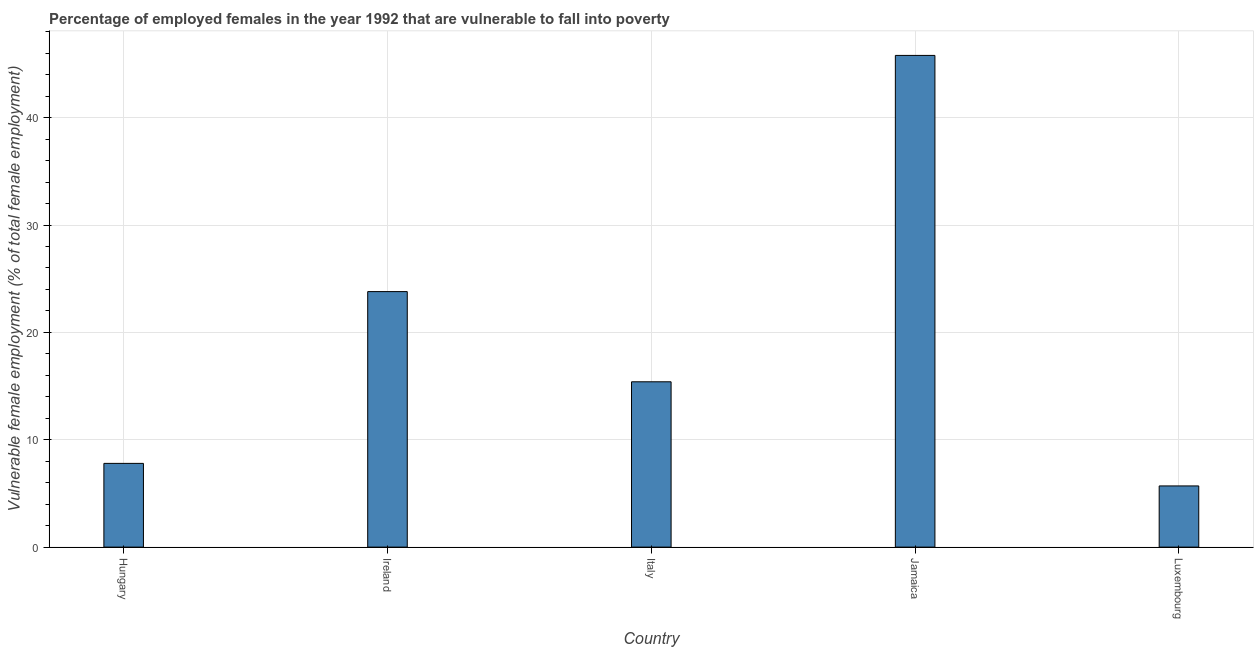What is the title of the graph?
Keep it short and to the point. Percentage of employed females in the year 1992 that are vulnerable to fall into poverty. What is the label or title of the X-axis?
Provide a short and direct response. Country. What is the label or title of the Y-axis?
Make the answer very short. Vulnerable female employment (% of total female employment). What is the percentage of employed females who are vulnerable to fall into poverty in Jamaica?
Provide a succinct answer. 45.8. Across all countries, what is the maximum percentage of employed females who are vulnerable to fall into poverty?
Offer a very short reply. 45.8. Across all countries, what is the minimum percentage of employed females who are vulnerable to fall into poverty?
Give a very brief answer. 5.7. In which country was the percentage of employed females who are vulnerable to fall into poverty maximum?
Ensure brevity in your answer.  Jamaica. In which country was the percentage of employed females who are vulnerable to fall into poverty minimum?
Your response must be concise. Luxembourg. What is the sum of the percentage of employed females who are vulnerable to fall into poverty?
Your answer should be compact. 98.5. What is the difference between the percentage of employed females who are vulnerable to fall into poverty in Ireland and Italy?
Make the answer very short. 8.4. What is the average percentage of employed females who are vulnerable to fall into poverty per country?
Provide a short and direct response. 19.7. What is the median percentage of employed females who are vulnerable to fall into poverty?
Ensure brevity in your answer.  15.4. In how many countries, is the percentage of employed females who are vulnerable to fall into poverty greater than 44 %?
Your answer should be very brief. 1. What is the ratio of the percentage of employed females who are vulnerable to fall into poverty in Italy to that in Jamaica?
Make the answer very short. 0.34. Is the difference between the percentage of employed females who are vulnerable to fall into poverty in Italy and Luxembourg greater than the difference between any two countries?
Your answer should be compact. No. Is the sum of the percentage of employed females who are vulnerable to fall into poverty in Italy and Jamaica greater than the maximum percentage of employed females who are vulnerable to fall into poverty across all countries?
Give a very brief answer. Yes. What is the difference between the highest and the lowest percentage of employed females who are vulnerable to fall into poverty?
Your answer should be compact. 40.1. In how many countries, is the percentage of employed females who are vulnerable to fall into poverty greater than the average percentage of employed females who are vulnerable to fall into poverty taken over all countries?
Make the answer very short. 2. How many bars are there?
Provide a succinct answer. 5. Are the values on the major ticks of Y-axis written in scientific E-notation?
Ensure brevity in your answer.  No. What is the Vulnerable female employment (% of total female employment) of Hungary?
Your answer should be compact. 7.8. What is the Vulnerable female employment (% of total female employment) of Ireland?
Offer a terse response. 23.8. What is the Vulnerable female employment (% of total female employment) of Italy?
Your response must be concise. 15.4. What is the Vulnerable female employment (% of total female employment) of Jamaica?
Give a very brief answer. 45.8. What is the Vulnerable female employment (% of total female employment) in Luxembourg?
Keep it short and to the point. 5.7. What is the difference between the Vulnerable female employment (% of total female employment) in Hungary and Ireland?
Ensure brevity in your answer.  -16. What is the difference between the Vulnerable female employment (% of total female employment) in Hungary and Italy?
Make the answer very short. -7.6. What is the difference between the Vulnerable female employment (% of total female employment) in Hungary and Jamaica?
Make the answer very short. -38. What is the difference between the Vulnerable female employment (% of total female employment) in Ireland and Italy?
Keep it short and to the point. 8.4. What is the difference between the Vulnerable female employment (% of total female employment) in Ireland and Jamaica?
Provide a succinct answer. -22. What is the difference between the Vulnerable female employment (% of total female employment) in Ireland and Luxembourg?
Offer a very short reply. 18.1. What is the difference between the Vulnerable female employment (% of total female employment) in Italy and Jamaica?
Offer a very short reply. -30.4. What is the difference between the Vulnerable female employment (% of total female employment) in Jamaica and Luxembourg?
Keep it short and to the point. 40.1. What is the ratio of the Vulnerable female employment (% of total female employment) in Hungary to that in Ireland?
Your response must be concise. 0.33. What is the ratio of the Vulnerable female employment (% of total female employment) in Hungary to that in Italy?
Your response must be concise. 0.51. What is the ratio of the Vulnerable female employment (% of total female employment) in Hungary to that in Jamaica?
Give a very brief answer. 0.17. What is the ratio of the Vulnerable female employment (% of total female employment) in Hungary to that in Luxembourg?
Keep it short and to the point. 1.37. What is the ratio of the Vulnerable female employment (% of total female employment) in Ireland to that in Italy?
Provide a short and direct response. 1.54. What is the ratio of the Vulnerable female employment (% of total female employment) in Ireland to that in Jamaica?
Offer a terse response. 0.52. What is the ratio of the Vulnerable female employment (% of total female employment) in Ireland to that in Luxembourg?
Offer a very short reply. 4.17. What is the ratio of the Vulnerable female employment (% of total female employment) in Italy to that in Jamaica?
Give a very brief answer. 0.34. What is the ratio of the Vulnerable female employment (% of total female employment) in Italy to that in Luxembourg?
Offer a terse response. 2.7. What is the ratio of the Vulnerable female employment (% of total female employment) in Jamaica to that in Luxembourg?
Give a very brief answer. 8.04. 